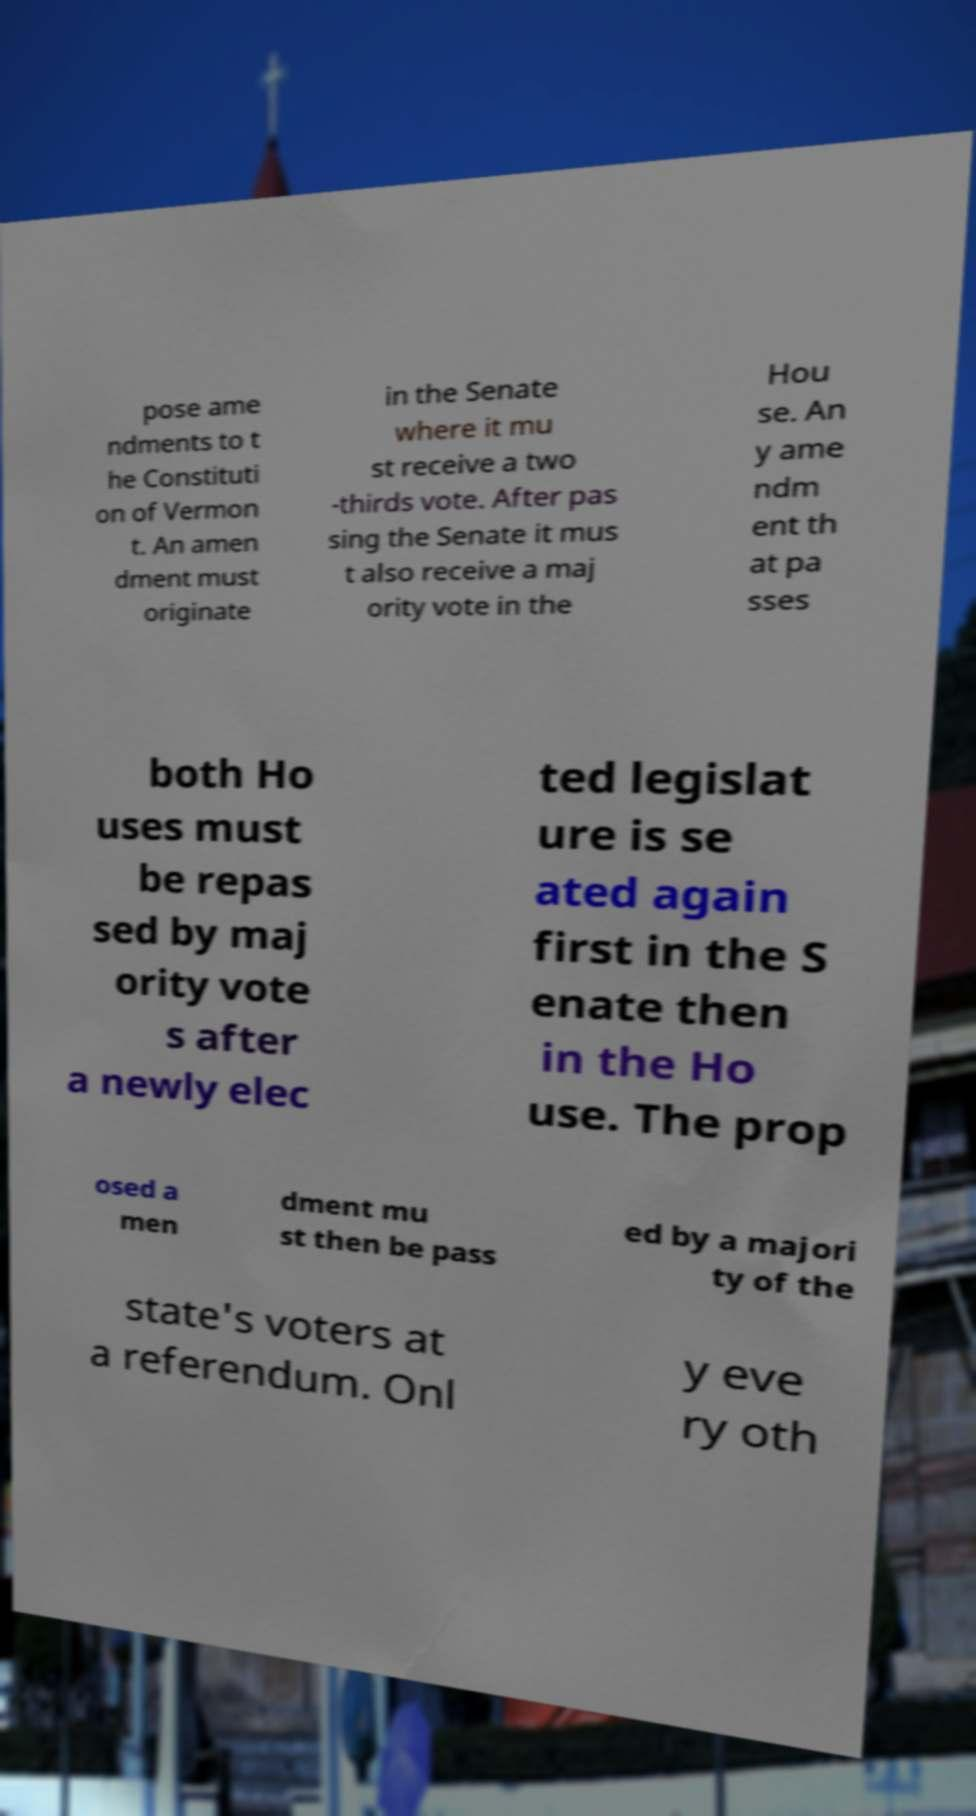Please identify and transcribe the text found in this image. pose ame ndments to t he Constituti on of Vermon t. An amen dment must originate in the Senate where it mu st receive a two -thirds vote. After pas sing the Senate it mus t also receive a maj ority vote in the Hou se. An y ame ndm ent th at pa sses both Ho uses must be repas sed by maj ority vote s after a newly elec ted legislat ure is se ated again first in the S enate then in the Ho use. The prop osed a men dment mu st then be pass ed by a majori ty of the state's voters at a referendum. Onl y eve ry oth 